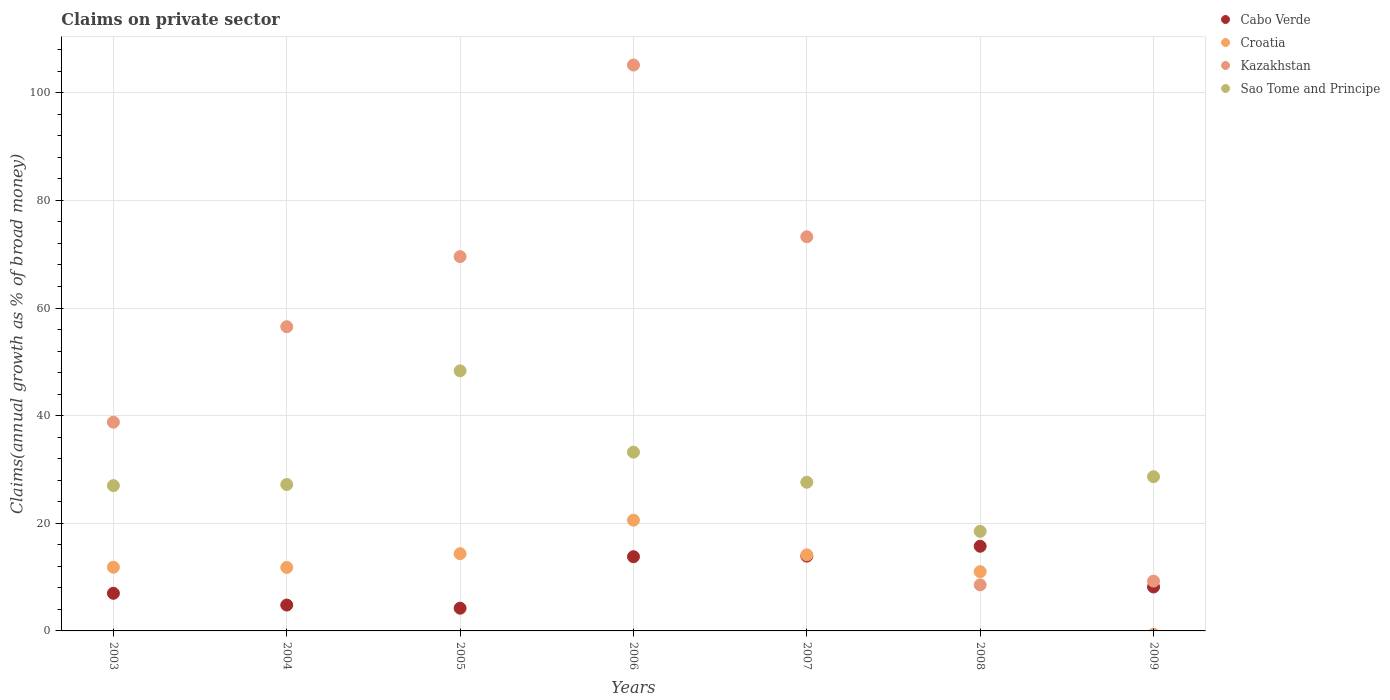How many different coloured dotlines are there?
Give a very brief answer. 4. What is the percentage of broad money claimed on private sector in Cabo Verde in 2009?
Your answer should be very brief. 8.17. Across all years, what is the maximum percentage of broad money claimed on private sector in Sao Tome and Principe?
Offer a very short reply. 48.33. Across all years, what is the minimum percentage of broad money claimed on private sector in Cabo Verde?
Your response must be concise. 4.22. In which year was the percentage of broad money claimed on private sector in Cabo Verde maximum?
Provide a short and direct response. 2008. What is the total percentage of broad money claimed on private sector in Croatia in the graph?
Your answer should be very brief. 83.72. What is the difference between the percentage of broad money claimed on private sector in Cabo Verde in 2006 and that in 2007?
Offer a very short reply. -0.11. What is the difference between the percentage of broad money claimed on private sector in Cabo Verde in 2006 and the percentage of broad money claimed on private sector in Croatia in 2005?
Provide a short and direct response. -0.56. What is the average percentage of broad money claimed on private sector in Cabo Verde per year?
Your answer should be compact. 9.66. In the year 2007, what is the difference between the percentage of broad money claimed on private sector in Croatia and percentage of broad money claimed on private sector in Cabo Verde?
Your answer should be compact. 0.24. In how many years, is the percentage of broad money claimed on private sector in Sao Tome and Principe greater than 52 %?
Keep it short and to the point. 0. What is the ratio of the percentage of broad money claimed on private sector in Kazakhstan in 2005 to that in 2008?
Give a very brief answer. 8.13. Is the percentage of broad money claimed on private sector in Kazakhstan in 2003 less than that in 2006?
Ensure brevity in your answer.  Yes. What is the difference between the highest and the second highest percentage of broad money claimed on private sector in Kazakhstan?
Your answer should be compact. 31.92. What is the difference between the highest and the lowest percentage of broad money claimed on private sector in Croatia?
Give a very brief answer. 20.58. In how many years, is the percentage of broad money claimed on private sector in Croatia greater than the average percentage of broad money claimed on private sector in Croatia taken over all years?
Offer a very short reply. 3. Is the sum of the percentage of broad money claimed on private sector in Kazakhstan in 2006 and 2008 greater than the maximum percentage of broad money claimed on private sector in Sao Tome and Principe across all years?
Give a very brief answer. Yes. Is it the case that in every year, the sum of the percentage of broad money claimed on private sector in Kazakhstan and percentage of broad money claimed on private sector in Sao Tome and Principe  is greater than the percentage of broad money claimed on private sector in Cabo Verde?
Give a very brief answer. Yes. Does the percentage of broad money claimed on private sector in Croatia monotonically increase over the years?
Your answer should be very brief. No. Is the percentage of broad money claimed on private sector in Kazakhstan strictly less than the percentage of broad money claimed on private sector in Sao Tome and Principe over the years?
Provide a succinct answer. No. How many dotlines are there?
Give a very brief answer. 4. What is the difference between two consecutive major ticks on the Y-axis?
Your answer should be compact. 20. Does the graph contain grids?
Keep it short and to the point. Yes. Where does the legend appear in the graph?
Offer a very short reply. Top right. How are the legend labels stacked?
Offer a terse response. Vertical. What is the title of the graph?
Your answer should be compact. Claims on private sector. Does "United States" appear as one of the legend labels in the graph?
Offer a terse response. No. What is the label or title of the X-axis?
Your answer should be compact. Years. What is the label or title of the Y-axis?
Ensure brevity in your answer.  Claims(annual growth as % of broad money). What is the Claims(annual growth as % of broad money) in Cabo Verde in 2003?
Your response must be concise. 6.99. What is the Claims(annual growth as % of broad money) in Croatia in 2003?
Offer a terse response. 11.84. What is the Claims(annual growth as % of broad money) in Kazakhstan in 2003?
Your answer should be very brief. 38.79. What is the Claims(annual growth as % of broad money) of Sao Tome and Principe in 2003?
Give a very brief answer. 27. What is the Claims(annual growth as % of broad money) of Cabo Verde in 2004?
Ensure brevity in your answer.  4.81. What is the Claims(annual growth as % of broad money) of Croatia in 2004?
Make the answer very short. 11.8. What is the Claims(annual growth as % of broad money) of Kazakhstan in 2004?
Offer a terse response. 56.53. What is the Claims(annual growth as % of broad money) of Sao Tome and Principe in 2004?
Your answer should be very brief. 27.21. What is the Claims(annual growth as % of broad money) in Cabo Verde in 2005?
Offer a terse response. 4.22. What is the Claims(annual growth as % of broad money) in Croatia in 2005?
Keep it short and to the point. 14.35. What is the Claims(annual growth as % of broad money) in Kazakhstan in 2005?
Give a very brief answer. 69.55. What is the Claims(annual growth as % of broad money) of Sao Tome and Principe in 2005?
Give a very brief answer. 48.33. What is the Claims(annual growth as % of broad money) in Cabo Verde in 2006?
Your answer should be compact. 13.79. What is the Claims(annual growth as % of broad money) of Croatia in 2006?
Provide a short and direct response. 20.58. What is the Claims(annual growth as % of broad money) in Kazakhstan in 2006?
Offer a terse response. 105.15. What is the Claims(annual growth as % of broad money) in Sao Tome and Principe in 2006?
Offer a terse response. 33.22. What is the Claims(annual growth as % of broad money) in Cabo Verde in 2007?
Provide a succinct answer. 13.9. What is the Claims(annual growth as % of broad money) in Croatia in 2007?
Provide a succinct answer. 14.14. What is the Claims(annual growth as % of broad money) in Kazakhstan in 2007?
Keep it short and to the point. 73.24. What is the Claims(annual growth as % of broad money) in Sao Tome and Principe in 2007?
Your response must be concise. 27.63. What is the Claims(annual growth as % of broad money) in Cabo Verde in 2008?
Make the answer very short. 15.73. What is the Claims(annual growth as % of broad money) in Croatia in 2008?
Your answer should be very brief. 11.01. What is the Claims(annual growth as % of broad money) of Kazakhstan in 2008?
Make the answer very short. 8.55. What is the Claims(annual growth as % of broad money) in Sao Tome and Principe in 2008?
Offer a very short reply. 18.51. What is the Claims(annual growth as % of broad money) of Cabo Verde in 2009?
Your answer should be compact. 8.17. What is the Claims(annual growth as % of broad money) in Croatia in 2009?
Offer a very short reply. 0. What is the Claims(annual growth as % of broad money) in Kazakhstan in 2009?
Your answer should be very brief. 9.25. What is the Claims(annual growth as % of broad money) of Sao Tome and Principe in 2009?
Your answer should be compact. 28.66. Across all years, what is the maximum Claims(annual growth as % of broad money) of Cabo Verde?
Your answer should be very brief. 15.73. Across all years, what is the maximum Claims(annual growth as % of broad money) of Croatia?
Offer a very short reply. 20.58. Across all years, what is the maximum Claims(annual growth as % of broad money) in Kazakhstan?
Provide a short and direct response. 105.15. Across all years, what is the maximum Claims(annual growth as % of broad money) of Sao Tome and Principe?
Offer a terse response. 48.33. Across all years, what is the minimum Claims(annual growth as % of broad money) in Cabo Verde?
Your answer should be very brief. 4.22. Across all years, what is the minimum Claims(annual growth as % of broad money) of Croatia?
Provide a succinct answer. 0. Across all years, what is the minimum Claims(annual growth as % of broad money) of Kazakhstan?
Give a very brief answer. 8.55. Across all years, what is the minimum Claims(annual growth as % of broad money) of Sao Tome and Principe?
Offer a terse response. 18.51. What is the total Claims(annual growth as % of broad money) in Cabo Verde in the graph?
Your answer should be very brief. 67.61. What is the total Claims(annual growth as % of broad money) in Croatia in the graph?
Provide a succinct answer. 83.72. What is the total Claims(annual growth as % of broad money) in Kazakhstan in the graph?
Your answer should be compact. 361.06. What is the total Claims(annual growth as % of broad money) of Sao Tome and Principe in the graph?
Your response must be concise. 210.55. What is the difference between the Claims(annual growth as % of broad money) of Cabo Verde in 2003 and that in 2004?
Keep it short and to the point. 2.19. What is the difference between the Claims(annual growth as % of broad money) of Croatia in 2003 and that in 2004?
Make the answer very short. 0.04. What is the difference between the Claims(annual growth as % of broad money) of Kazakhstan in 2003 and that in 2004?
Make the answer very short. -17.74. What is the difference between the Claims(annual growth as % of broad money) in Sao Tome and Principe in 2003 and that in 2004?
Give a very brief answer. -0.21. What is the difference between the Claims(annual growth as % of broad money) in Cabo Verde in 2003 and that in 2005?
Provide a short and direct response. 2.77. What is the difference between the Claims(annual growth as % of broad money) in Croatia in 2003 and that in 2005?
Ensure brevity in your answer.  -2.51. What is the difference between the Claims(annual growth as % of broad money) of Kazakhstan in 2003 and that in 2005?
Your answer should be compact. -30.76. What is the difference between the Claims(annual growth as % of broad money) of Sao Tome and Principe in 2003 and that in 2005?
Provide a short and direct response. -21.33. What is the difference between the Claims(annual growth as % of broad money) in Cabo Verde in 2003 and that in 2006?
Offer a terse response. -6.8. What is the difference between the Claims(annual growth as % of broad money) of Croatia in 2003 and that in 2006?
Keep it short and to the point. -8.74. What is the difference between the Claims(annual growth as % of broad money) of Kazakhstan in 2003 and that in 2006?
Give a very brief answer. -66.36. What is the difference between the Claims(annual growth as % of broad money) in Sao Tome and Principe in 2003 and that in 2006?
Make the answer very short. -6.22. What is the difference between the Claims(annual growth as % of broad money) of Cabo Verde in 2003 and that in 2007?
Provide a short and direct response. -6.91. What is the difference between the Claims(annual growth as % of broad money) in Croatia in 2003 and that in 2007?
Your response must be concise. -2.31. What is the difference between the Claims(annual growth as % of broad money) of Kazakhstan in 2003 and that in 2007?
Your answer should be very brief. -34.45. What is the difference between the Claims(annual growth as % of broad money) in Sao Tome and Principe in 2003 and that in 2007?
Provide a succinct answer. -0.63. What is the difference between the Claims(annual growth as % of broad money) in Cabo Verde in 2003 and that in 2008?
Keep it short and to the point. -8.74. What is the difference between the Claims(annual growth as % of broad money) of Croatia in 2003 and that in 2008?
Ensure brevity in your answer.  0.83. What is the difference between the Claims(annual growth as % of broad money) in Kazakhstan in 2003 and that in 2008?
Your response must be concise. 30.24. What is the difference between the Claims(annual growth as % of broad money) in Sao Tome and Principe in 2003 and that in 2008?
Make the answer very short. 8.49. What is the difference between the Claims(annual growth as % of broad money) of Cabo Verde in 2003 and that in 2009?
Give a very brief answer. -1.18. What is the difference between the Claims(annual growth as % of broad money) in Kazakhstan in 2003 and that in 2009?
Give a very brief answer. 29.54. What is the difference between the Claims(annual growth as % of broad money) in Sao Tome and Principe in 2003 and that in 2009?
Keep it short and to the point. -1.66. What is the difference between the Claims(annual growth as % of broad money) of Cabo Verde in 2004 and that in 2005?
Your response must be concise. 0.59. What is the difference between the Claims(annual growth as % of broad money) in Croatia in 2004 and that in 2005?
Give a very brief answer. -2.56. What is the difference between the Claims(annual growth as % of broad money) in Kazakhstan in 2004 and that in 2005?
Ensure brevity in your answer.  -13.02. What is the difference between the Claims(annual growth as % of broad money) in Sao Tome and Principe in 2004 and that in 2005?
Ensure brevity in your answer.  -21.12. What is the difference between the Claims(annual growth as % of broad money) of Cabo Verde in 2004 and that in 2006?
Give a very brief answer. -8.98. What is the difference between the Claims(annual growth as % of broad money) in Croatia in 2004 and that in 2006?
Your response must be concise. -8.78. What is the difference between the Claims(annual growth as % of broad money) in Kazakhstan in 2004 and that in 2006?
Give a very brief answer. -48.63. What is the difference between the Claims(annual growth as % of broad money) in Sao Tome and Principe in 2004 and that in 2006?
Offer a terse response. -6.01. What is the difference between the Claims(annual growth as % of broad money) in Cabo Verde in 2004 and that in 2007?
Your response must be concise. -9.09. What is the difference between the Claims(annual growth as % of broad money) of Croatia in 2004 and that in 2007?
Your answer should be very brief. -2.35. What is the difference between the Claims(annual growth as % of broad money) of Kazakhstan in 2004 and that in 2007?
Your response must be concise. -16.71. What is the difference between the Claims(annual growth as % of broad money) in Sao Tome and Principe in 2004 and that in 2007?
Give a very brief answer. -0.42. What is the difference between the Claims(annual growth as % of broad money) of Cabo Verde in 2004 and that in 2008?
Provide a short and direct response. -10.92. What is the difference between the Claims(annual growth as % of broad money) in Croatia in 2004 and that in 2008?
Offer a very short reply. 0.79. What is the difference between the Claims(annual growth as % of broad money) in Kazakhstan in 2004 and that in 2008?
Offer a terse response. 47.97. What is the difference between the Claims(annual growth as % of broad money) of Sao Tome and Principe in 2004 and that in 2008?
Your response must be concise. 8.7. What is the difference between the Claims(annual growth as % of broad money) in Cabo Verde in 2004 and that in 2009?
Your answer should be compact. -3.37. What is the difference between the Claims(annual growth as % of broad money) of Kazakhstan in 2004 and that in 2009?
Provide a short and direct response. 47.28. What is the difference between the Claims(annual growth as % of broad money) in Sao Tome and Principe in 2004 and that in 2009?
Provide a short and direct response. -1.45. What is the difference between the Claims(annual growth as % of broad money) of Cabo Verde in 2005 and that in 2006?
Your answer should be compact. -9.57. What is the difference between the Claims(annual growth as % of broad money) of Croatia in 2005 and that in 2006?
Offer a terse response. -6.23. What is the difference between the Claims(annual growth as % of broad money) of Kazakhstan in 2005 and that in 2006?
Ensure brevity in your answer.  -35.6. What is the difference between the Claims(annual growth as % of broad money) of Sao Tome and Principe in 2005 and that in 2006?
Offer a very short reply. 15.12. What is the difference between the Claims(annual growth as % of broad money) of Cabo Verde in 2005 and that in 2007?
Ensure brevity in your answer.  -9.68. What is the difference between the Claims(annual growth as % of broad money) in Croatia in 2005 and that in 2007?
Give a very brief answer. 0.21. What is the difference between the Claims(annual growth as % of broad money) of Kazakhstan in 2005 and that in 2007?
Offer a very short reply. -3.69. What is the difference between the Claims(annual growth as % of broad money) in Sao Tome and Principe in 2005 and that in 2007?
Offer a very short reply. 20.7. What is the difference between the Claims(annual growth as % of broad money) in Cabo Verde in 2005 and that in 2008?
Provide a succinct answer. -11.51. What is the difference between the Claims(annual growth as % of broad money) of Croatia in 2005 and that in 2008?
Provide a succinct answer. 3.34. What is the difference between the Claims(annual growth as % of broad money) in Kazakhstan in 2005 and that in 2008?
Make the answer very short. 61. What is the difference between the Claims(annual growth as % of broad money) in Sao Tome and Principe in 2005 and that in 2008?
Give a very brief answer. 29.83. What is the difference between the Claims(annual growth as % of broad money) in Cabo Verde in 2005 and that in 2009?
Ensure brevity in your answer.  -3.95. What is the difference between the Claims(annual growth as % of broad money) of Kazakhstan in 2005 and that in 2009?
Ensure brevity in your answer.  60.3. What is the difference between the Claims(annual growth as % of broad money) in Sao Tome and Principe in 2005 and that in 2009?
Your response must be concise. 19.67. What is the difference between the Claims(annual growth as % of broad money) of Cabo Verde in 2006 and that in 2007?
Offer a terse response. -0.11. What is the difference between the Claims(annual growth as % of broad money) of Croatia in 2006 and that in 2007?
Your answer should be very brief. 6.44. What is the difference between the Claims(annual growth as % of broad money) in Kazakhstan in 2006 and that in 2007?
Offer a very short reply. 31.92. What is the difference between the Claims(annual growth as % of broad money) of Sao Tome and Principe in 2006 and that in 2007?
Provide a succinct answer. 5.59. What is the difference between the Claims(annual growth as % of broad money) of Cabo Verde in 2006 and that in 2008?
Your answer should be very brief. -1.94. What is the difference between the Claims(annual growth as % of broad money) of Croatia in 2006 and that in 2008?
Make the answer very short. 9.57. What is the difference between the Claims(annual growth as % of broad money) in Kazakhstan in 2006 and that in 2008?
Provide a succinct answer. 96.6. What is the difference between the Claims(annual growth as % of broad money) of Sao Tome and Principe in 2006 and that in 2008?
Keep it short and to the point. 14.71. What is the difference between the Claims(annual growth as % of broad money) of Cabo Verde in 2006 and that in 2009?
Provide a succinct answer. 5.62. What is the difference between the Claims(annual growth as % of broad money) in Kazakhstan in 2006 and that in 2009?
Give a very brief answer. 95.9. What is the difference between the Claims(annual growth as % of broad money) in Sao Tome and Principe in 2006 and that in 2009?
Offer a very short reply. 4.56. What is the difference between the Claims(annual growth as % of broad money) in Cabo Verde in 2007 and that in 2008?
Make the answer very short. -1.83. What is the difference between the Claims(annual growth as % of broad money) in Croatia in 2007 and that in 2008?
Your answer should be compact. 3.14. What is the difference between the Claims(annual growth as % of broad money) of Kazakhstan in 2007 and that in 2008?
Your answer should be very brief. 64.68. What is the difference between the Claims(annual growth as % of broad money) of Sao Tome and Principe in 2007 and that in 2008?
Your answer should be compact. 9.12. What is the difference between the Claims(annual growth as % of broad money) of Cabo Verde in 2007 and that in 2009?
Your response must be concise. 5.73. What is the difference between the Claims(annual growth as % of broad money) of Kazakhstan in 2007 and that in 2009?
Ensure brevity in your answer.  63.98. What is the difference between the Claims(annual growth as % of broad money) of Sao Tome and Principe in 2007 and that in 2009?
Provide a succinct answer. -1.03. What is the difference between the Claims(annual growth as % of broad money) of Cabo Verde in 2008 and that in 2009?
Give a very brief answer. 7.56. What is the difference between the Claims(annual growth as % of broad money) of Kazakhstan in 2008 and that in 2009?
Ensure brevity in your answer.  -0.7. What is the difference between the Claims(annual growth as % of broad money) in Sao Tome and Principe in 2008 and that in 2009?
Your response must be concise. -10.15. What is the difference between the Claims(annual growth as % of broad money) of Cabo Verde in 2003 and the Claims(annual growth as % of broad money) of Croatia in 2004?
Keep it short and to the point. -4.8. What is the difference between the Claims(annual growth as % of broad money) in Cabo Verde in 2003 and the Claims(annual growth as % of broad money) in Kazakhstan in 2004?
Your answer should be very brief. -49.54. What is the difference between the Claims(annual growth as % of broad money) in Cabo Verde in 2003 and the Claims(annual growth as % of broad money) in Sao Tome and Principe in 2004?
Your answer should be very brief. -20.22. What is the difference between the Claims(annual growth as % of broad money) in Croatia in 2003 and the Claims(annual growth as % of broad money) in Kazakhstan in 2004?
Keep it short and to the point. -44.69. What is the difference between the Claims(annual growth as % of broad money) of Croatia in 2003 and the Claims(annual growth as % of broad money) of Sao Tome and Principe in 2004?
Your response must be concise. -15.37. What is the difference between the Claims(annual growth as % of broad money) of Kazakhstan in 2003 and the Claims(annual growth as % of broad money) of Sao Tome and Principe in 2004?
Make the answer very short. 11.58. What is the difference between the Claims(annual growth as % of broad money) of Cabo Verde in 2003 and the Claims(annual growth as % of broad money) of Croatia in 2005?
Keep it short and to the point. -7.36. What is the difference between the Claims(annual growth as % of broad money) in Cabo Verde in 2003 and the Claims(annual growth as % of broad money) in Kazakhstan in 2005?
Give a very brief answer. -62.56. What is the difference between the Claims(annual growth as % of broad money) of Cabo Verde in 2003 and the Claims(annual growth as % of broad money) of Sao Tome and Principe in 2005?
Your answer should be compact. -41.34. What is the difference between the Claims(annual growth as % of broad money) in Croatia in 2003 and the Claims(annual growth as % of broad money) in Kazakhstan in 2005?
Keep it short and to the point. -57.71. What is the difference between the Claims(annual growth as % of broad money) of Croatia in 2003 and the Claims(annual growth as % of broad money) of Sao Tome and Principe in 2005?
Ensure brevity in your answer.  -36.5. What is the difference between the Claims(annual growth as % of broad money) of Kazakhstan in 2003 and the Claims(annual growth as % of broad money) of Sao Tome and Principe in 2005?
Offer a very short reply. -9.54. What is the difference between the Claims(annual growth as % of broad money) of Cabo Verde in 2003 and the Claims(annual growth as % of broad money) of Croatia in 2006?
Provide a succinct answer. -13.59. What is the difference between the Claims(annual growth as % of broad money) of Cabo Verde in 2003 and the Claims(annual growth as % of broad money) of Kazakhstan in 2006?
Make the answer very short. -98.16. What is the difference between the Claims(annual growth as % of broad money) in Cabo Verde in 2003 and the Claims(annual growth as % of broad money) in Sao Tome and Principe in 2006?
Your answer should be very brief. -26.22. What is the difference between the Claims(annual growth as % of broad money) in Croatia in 2003 and the Claims(annual growth as % of broad money) in Kazakhstan in 2006?
Provide a succinct answer. -93.32. What is the difference between the Claims(annual growth as % of broad money) in Croatia in 2003 and the Claims(annual growth as % of broad money) in Sao Tome and Principe in 2006?
Ensure brevity in your answer.  -21.38. What is the difference between the Claims(annual growth as % of broad money) of Kazakhstan in 2003 and the Claims(annual growth as % of broad money) of Sao Tome and Principe in 2006?
Your answer should be compact. 5.57. What is the difference between the Claims(annual growth as % of broad money) in Cabo Verde in 2003 and the Claims(annual growth as % of broad money) in Croatia in 2007?
Provide a succinct answer. -7.15. What is the difference between the Claims(annual growth as % of broad money) in Cabo Verde in 2003 and the Claims(annual growth as % of broad money) in Kazakhstan in 2007?
Give a very brief answer. -66.24. What is the difference between the Claims(annual growth as % of broad money) in Cabo Verde in 2003 and the Claims(annual growth as % of broad money) in Sao Tome and Principe in 2007?
Keep it short and to the point. -20.64. What is the difference between the Claims(annual growth as % of broad money) of Croatia in 2003 and the Claims(annual growth as % of broad money) of Kazakhstan in 2007?
Give a very brief answer. -61.4. What is the difference between the Claims(annual growth as % of broad money) of Croatia in 2003 and the Claims(annual growth as % of broad money) of Sao Tome and Principe in 2007?
Your response must be concise. -15.79. What is the difference between the Claims(annual growth as % of broad money) of Kazakhstan in 2003 and the Claims(annual growth as % of broad money) of Sao Tome and Principe in 2007?
Your answer should be compact. 11.16. What is the difference between the Claims(annual growth as % of broad money) in Cabo Verde in 2003 and the Claims(annual growth as % of broad money) in Croatia in 2008?
Keep it short and to the point. -4.02. What is the difference between the Claims(annual growth as % of broad money) in Cabo Verde in 2003 and the Claims(annual growth as % of broad money) in Kazakhstan in 2008?
Make the answer very short. -1.56. What is the difference between the Claims(annual growth as % of broad money) of Cabo Verde in 2003 and the Claims(annual growth as % of broad money) of Sao Tome and Principe in 2008?
Provide a short and direct response. -11.51. What is the difference between the Claims(annual growth as % of broad money) in Croatia in 2003 and the Claims(annual growth as % of broad money) in Kazakhstan in 2008?
Offer a very short reply. 3.28. What is the difference between the Claims(annual growth as % of broad money) in Croatia in 2003 and the Claims(annual growth as % of broad money) in Sao Tome and Principe in 2008?
Your answer should be compact. -6.67. What is the difference between the Claims(annual growth as % of broad money) in Kazakhstan in 2003 and the Claims(annual growth as % of broad money) in Sao Tome and Principe in 2008?
Offer a very short reply. 20.28. What is the difference between the Claims(annual growth as % of broad money) in Cabo Verde in 2003 and the Claims(annual growth as % of broad money) in Kazakhstan in 2009?
Your answer should be very brief. -2.26. What is the difference between the Claims(annual growth as % of broad money) of Cabo Verde in 2003 and the Claims(annual growth as % of broad money) of Sao Tome and Principe in 2009?
Offer a terse response. -21.67. What is the difference between the Claims(annual growth as % of broad money) in Croatia in 2003 and the Claims(annual growth as % of broad money) in Kazakhstan in 2009?
Ensure brevity in your answer.  2.59. What is the difference between the Claims(annual growth as % of broad money) in Croatia in 2003 and the Claims(annual growth as % of broad money) in Sao Tome and Principe in 2009?
Keep it short and to the point. -16.82. What is the difference between the Claims(annual growth as % of broad money) in Kazakhstan in 2003 and the Claims(annual growth as % of broad money) in Sao Tome and Principe in 2009?
Your response must be concise. 10.13. What is the difference between the Claims(annual growth as % of broad money) in Cabo Verde in 2004 and the Claims(annual growth as % of broad money) in Croatia in 2005?
Your answer should be very brief. -9.54. What is the difference between the Claims(annual growth as % of broad money) of Cabo Verde in 2004 and the Claims(annual growth as % of broad money) of Kazakhstan in 2005?
Offer a very short reply. -64.75. What is the difference between the Claims(annual growth as % of broad money) in Cabo Verde in 2004 and the Claims(annual growth as % of broad money) in Sao Tome and Principe in 2005?
Offer a terse response. -43.53. What is the difference between the Claims(annual growth as % of broad money) in Croatia in 2004 and the Claims(annual growth as % of broad money) in Kazakhstan in 2005?
Provide a succinct answer. -57.76. What is the difference between the Claims(annual growth as % of broad money) of Croatia in 2004 and the Claims(annual growth as % of broad money) of Sao Tome and Principe in 2005?
Provide a short and direct response. -36.54. What is the difference between the Claims(annual growth as % of broad money) of Kazakhstan in 2004 and the Claims(annual growth as % of broad money) of Sao Tome and Principe in 2005?
Offer a terse response. 8.19. What is the difference between the Claims(annual growth as % of broad money) in Cabo Verde in 2004 and the Claims(annual growth as % of broad money) in Croatia in 2006?
Ensure brevity in your answer.  -15.77. What is the difference between the Claims(annual growth as % of broad money) of Cabo Verde in 2004 and the Claims(annual growth as % of broad money) of Kazakhstan in 2006?
Your answer should be very brief. -100.35. What is the difference between the Claims(annual growth as % of broad money) in Cabo Verde in 2004 and the Claims(annual growth as % of broad money) in Sao Tome and Principe in 2006?
Provide a succinct answer. -28.41. What is the difference between the Claims(annual growth as % of broad money) of Croatia in 2004 and the Claims(annual growth as % of broad money) of Kazakhstan in 2006?
Ensure brevity in your answer.  -93.36. What is the difference between the Claims(annual growth as % of broad money) of Croatia in 2004 and the Claims(annual growth as % of broad money) of Sao Tome and Principe in 2006?
Offer a very short reply. -21.42. What is the difference between the Claims(annual growth as % of broad money) of Kazakhstan in 2004 and the Claims(annual growth as % of broad money) of Sao Tome and Principe in 2006?
Provide a succinct answer. 23.31. What is the difference between the Claims(annual growth as % of broad money) of Cabo Verde in 2004 and the Claims(annual growth as % of broad money) of Croatia in 2007?
Ensure brevity in your answer.  -9.34. What is the difference between the Claims(annual growth as % of broad money) in Cabo Verde in 2004 and the Claims(annual growth as % of broad money) in Kazakhstan in 2007?
Ensure brevity in your answer.  -68.43. What is the difference between the Claims(annual growth as % of broad money) of Cabo Verde in 2004 and the Claims(annual growth as % of broad money) of Sao Tome and Principe in 2007?
Give a very brief answer. -22.82. What is the difference between the Claims(annual growth as % of broad money) of Croatia in 2004 and the Claims(annual growth as % of broad money) of Kazakhstan in 2007?
Your answer should be very brief. -61.44. What is the difference between the Claims(annual growth as % of broad money) in Croatia in 2004 and the Claims(annual growth as % of broad money) in Sao Tome and Principe in 2007?
Make the answer very short. -15.84. What is the difference between the Claims(annual growth as % of broad money) of Kazakhstan in 2004 and the Claims(annual growth as % of broad money) of Sao Tome and Principe in 2007?
Ensure brevity in your answer.  28.9. What is the difference between the Claims(annual growth as % of broad money) of Cabo Verde in 2004 and the Claims(annual growth as % of broad money) of Croatia in 2008?
Your response must be concise. -6.2. What is the difference between the Claims(annual growth as % of broad money) in Cabo Verde in 2004 and the Claims(annual growth as % of broad money) in Kazakhstan in 2008?
Your response must be concise. -3.75. What is the difference between the Claims(annual growth as % of broad money) in Cabo Verde in 2004 and the Claims(annual growth as % of broad money) in Sao Tome and Principe in 2008?
Give a very brief answer. -13.7. What is the difference between the Claims(annual growth as % of broad money) in Croatia in 2004 and the Claims(annual growth as % of broad money) in Kazakhstan in 2008?
Provide a short and direct response. 3.24. What is the difference between the Claims(annual growth as % of broad money) in Croatia in 2004 and the Claims(annual growth as % of broad money) in Sao Tome and Principe in 2008?
Keep it short and to the point. -6.71. What is the difference between the Claims(annual growth as % of broad money) of Kazakhstan in 2004 and the Claims(annual growth as % of broad money) of Sao Tome and Principe in 2008?
Provide a short and direct response. 38.02. What is the difference between the Claims(annual growth as % of broad money) in Cabo Verde in 2004 and the Claims(annual growth as % of broad money) in Kazakhstan in 2009?
Keep it short and to the point. -4.45. What is the difference between the Claims(annual growth as % of broad money) of Cabo Verde in 2004 and the Claims(annual growth as % of broad money) of Sao Tome and Principe in 2009?
Your response must be concise. -23.85. What is the difference between the Claims(annual growth as % of broad money) of Croatia in 2004 and the Claims(annual growth as % of broad money) of Kazakhstan in 2009?
Offer a very short reply. 2.54. What is the difference between the Claims(annual growth as % of broad money) of Croatia in 2004 and the Claims(annual growth as % of broad money) of Sao Tome and Principe in 2009?
Your response must be concise. -16.86. What is the difference between the Claims(annual growth as % of broad money) in Kazakhstan in 2004 and the Claims(annual growth as % of broad money) in Sao Tome and Principe in 2009?
Offer a very short reply. 27.87. What is the difference between the Claims(annual growth as % of broad money) of Cabo Verde in 2005 and the Claims(annual growth as % of broad money) of Croatia in 2006?
Your response must be concise. -16.36. What is the difference between the Claims(annual growth as % of broad money) in Cabo Verde in 2005 and the Claims(annual growth as % of broad money) in Kazakhstan in 2006?
Ensure brevity in your answer.  -100.93. What is the difference between the Claims(annual growth as % of broad money) of Cabo Verde in 2005 and the Claims(annual growth as % of broad money) of Sao Tome and Principe in 2006?
Offer a very short reply. -29. What is the difference between the Claims(annual growth as % of broad money) in Croatia in 2005 and the Claims(annual growth as % of broad money) in Kazakhstan in 2006?
Your answer should be compact. -90.8. What is the difference between the Claims(annual growth as % of broad money) of Croatia in 2005 and the Claims(annual growth as % of broad money) of Sao Tome and Principe in 2006?
Offer a very short reply. -18.87. What is the difference between the Claims(annual growth as % of broad money) in Kazakhstan in 2005 and the Claims(annual growth as % of broad money) in Sao Tome and Principe in 2006?
Offer a terse response. 36.34. What is the difference between the Claims(annual growth as % of broad money) in Cabo Verde in 2005 and the Claims(annual growth as % of broad money) in Croatia in 2007?
Your answer should be very brief. -9.92. What is the difference between the Claims(annual growth as % of broad money) of Cabo Verde in 2005 and the Claims(annual growth as % of broad money) of Kazakhstan in 2007?
Make the answer very short. -69.02. What is the difference between the Claims(annual growth as % of broad money) of Cabo Verde in 2005 and the Claims(annual growth as % of broad money) of Sao Tome and Principe in 2007?
Your answer should be compact. -23.41. What is the difference between the Claims(annual growth as % of broad money) of Croatia in 2005 and the Claims(annual growth as % of broad money) of Kazakhstan in 2007?
Provide a succinct answer. -58.89. What is the difference between the Claims(annual growth as % of broad money) of Croatia in 2005 and the Claims(annual growth as % of broad money) of Sao Tome and Principe in 2007?
Your answer should be very brief. -13.28. What is the difference between the Claims(annual growth as % of broad money) of Kazakhstan in 2005 and the Claims(annual growth as % of broad money) of Sao Tome and Principe in 2007?
Your response must be concise. 41.92. What is the difference between the Claims(annual growth as % of broad money) in Cabo Verde in 2005 and the Claims(annual growth as % of broad money) in Croatia in 2008?
Ensure brevity in your answer.  -6.79. What is the difference between the Claims(annual growth as % of broad money) of Cabo Verde in 2005 and the Claims(annual growth as % of broad money) of Kazakhstan in 2008?
Offer a terse response. -4.33. What is the difference between the Claims(annual growth as % of broad money) of Cabo Verde in 2005 and the Claims(annual growth as % of broad money) of Sao Tome and Principe in 2008?
Offer a terse response. -14.29. What is the difference between the Claims(annual growth as % of broad money) in Croatia in 2005 and the Claims(annual growth as % of broad money) in Kazakhstan in 2008?
Provide a succinct answer. 5.8. What is the difference between the Claims(annual growth as % of broad money) in Croatia in 2005 and the Claims(annual growth as % of broad money) in Sao Tome and Principe in 2008?
Offer a terse response. -4.15. What is the difference between the Claims(annual growth as % of broad money) of Kazakhstan in 2005 and the Claims(annual growth as % of broad money) of Sao Tome and Principe in 2008?
Make the answer very short. 51.05. What is the difference between the Claims(annual growth as % of broad money) of Cabo Verde in 2005 and the Claims(annual growth as % of broad money) of Kazakhstan in 2009?
Your answer should be very brief. -5.03. What is the difference between the Claims(annual growth as % of broad money) in Cabo Verde in 2005 and the Claims(annual growth as % of broad money) in Sao Tome and Principe in 2009?
Provide a short and direct response. -24.44. What is the difference between the Claims(annual growth as % of broad money) in Croatia in 2005 and the Claims(annual growth as % of broad money) in Kazakhstan in 2009?
Offer a very short reply. 5.1. What is the difference between the Claims(annual growth as % of broad money) of Croatia in 2005 and the Claims(annual growth as % of broad money) of Sao Tome and Principe in 2009?
Offer a very short reply. -14.31. What is the difference between the Claims(annual growth as % of broad money) in Kazakhstan in 2005 and the Claims(annual growth as % of broad money) in Sao Tome and Principe in 2009?
Provide a short and direct response. 40.89. What is the difference between the Claims(annual growth as % of broad money) in Cabo Verde in 2006 and the Claims(annual growth as % of broad money) in Croatia in 2007?
Offer a very short reply. -0.35. What is the difference between the Claims(annual growth as % of broad money) in Cabo Verde in 2006 and the Claims(annual growth as % of broad money) in Kazakhstan in 2007?
Your answer should be compact. -59.45. What is the difference between the Claims(annual growth as % of broad money) of Cabo Verde in 2006 and the Claims(annual growth as % of broad money) of Sao Tome and Principe in 2007?
Give a very brief answer. -13.84. What is the difference between the Claims(annual growth as % of broad money) of Croatia in 2006 and the Claims(annual growth as % of broad money) of Kazakhstan in 2007?
Provide a short and direct response. -52.66. What is the difference between the Claims(annual growth as % of broad money) of Croatia in 2006 and the Claims(annual growth as % of broad money) of Sao Tome and Principe in 2007?
Give a very brief answer. -7.05. What is the difference between the Claims(annual growth as % of broad money) of Kazakhstan in 2006 and the Claims(annual growth as % of broad money) of Sao Tome and Principe in 2007?
Provide a succinct answer. 77.52. What is the difference between the Claims(annual growth as % of broad money) of Cabo Verde in 2006 and the Claims(annual growth as % of broad money) of Croatia in 2008?
Offer a terse response. 2.78. What is the difference between the Claims(annual growth as % of broad money) of Cabo Verde in 2006 and the Claims(annual growth as % of broad money) of Kazakhstan in 2008?
Keep it short and to the point. 5.24. What is the difference between the Claims(annual growth as % of broad money) in Cabo Verde in 2006 and the Claims(annual growth as % of broad money) in Sao Tome and Principe in 2008?
Make the answer very short. -4.71. What is the difference between the Claims(annual growth as % of broad money) of Croatia in 2006 and the Claims(annual growth as % of broad money) of Kazakhstan in 2008?
Provide a short and direct response. 12.03. What is the difference between the Claims(annual growth as % of broad money) in Croatia in 2006 and the Claims(annual growth as % of broad money) in Sao Tome and Principe in 2008?
Offer a terse response. 2.07. What is the difference between the Claims(annual growth as % of broad money) in Kazakhstan in 2006 and the Claims(annual growth as % of broad money) in Sao Tome and Principe in 2008?
Give a very brief answer. 86.65. What is the difference between the Claims(annual growth as % of broad money) of Cabo Verde in 2006 and the Claims(annual growth as % of broad money) of Kazakhstan in 2009?
Your answer should be compact. 4.54. What is the difference between the Claims(annual growth as % of broad money) of Cabo Verde in 2006 and the Claims(annual growth as % of broad money) of Sao Tome and Principe in 2009?
Your answer should be very brief. -14.87. What is the difference between the Claims(annual growth as % of broad money) in Croatia in 2006 and the Claims(annual growth as % of broad money) in Kazakhstan in 2009?
Ensure brevity in your answer.  11.33. What is the difference between the Claims(annual growth as % of broad money) in Croatia in 2006 and the Claims(annual growth as % of broad money) in Sao Tome and Principe in 2009?
Your answer should be very brief. -8.08. What is the difference between the Claims(annual growth as % of broad money) in Kazakhstan in 2006 and the Claims(annual growth as % of broad money) in Sao Tome and Principe in 2009?
Your answer should be very brief. 76.49. What is the difference between the Claims(annual growth as % of broad money) in Cabo Verde in 2007 and the Claims(annual growth as % of broad money) in Croatia in 2008?
Offer a terse response. 2.89. What is the difference between the Claims(annual growth as % of broad money) in Cabo Verde in 2007 and the Claims(annual growth as % of broad money) in Kazakhstan in 2008?
Your answer should be compact. 5.35. What is the difference between the Claims(annual growth as % of broad money) in Cabo Verde in 2007 and the Claims(annual growth as % of broad money) in Sao Tome and Principe in 2008?
Offer a terse response. -4.61. What is the difference between the Claims(annual growth as % of broad money) of Croatia in 2007 and the Claims(annual growth as % of broad money) of Kazakhstan in 2008?
Provide a short and direct response. 5.59. What is the difference between the Claims(annual growth as % of broad money) in Croatia in 2007 and the Claims(annual growth as % of broad money) in Sao Tome and Principe in 2008?
Keep it short and to the point. -4.36. What is the difference between the Claims(annual growth as % of broad money) of Kazakhstan in 2007 and the Claims(annual growth as % of broad money) of Sao Tome and Principe in 2008?
Your answer should be compact. 54.73. What is the difference between the Claims(annual growth as % of broad money) of Cabo Verde in 2007 and the Claims(annual growth as % of broad money) of Kazakhstan in 2009?
Offer a very short reply. 4.65. What is the difference between the Claims(annual growth as % of broad money) of Cabo Verde in 2007 and the Claims(annual growth as % of broad money) of Sao Tome and Principe in 2009?
Provide a succinct answer. -14.76. What is the difference between the Claims(annual growth as % of broad money) of Croatia in 2007 and the Claims(annual growth as % of broad money) of Kazakhstan in 2009?
Offer a terse response. 4.89. What is the difference between the Claims(annual growth as % of broad money) of Croatia in 2007 and the Claims(annual growth as % of broad money) of Sao Tome and Principe in 2009?
Your answer should be compact. -14.52. What is the difference between the Claims(annual growth as % of broad money) in Kazakhstan in 2007 and the Claims(annual growth as % of broad money) in Sao Tome and Principe in 2009?
Provide a succinct answer. 44.58. What is the difference between the Claims(annual growth as % of broad money) of Cabo Verde in 2008 and the Claims(annual growth as % of broad money) of Kazakhstan in 2009?
Give a very brief answer. 6.48. What is the difference between the Claims(annual growth as % of broad money) in Cabo Verde in 2008 and the Claims(annual growth as % of broad money) in Sao Tome and Principe in 2009?
Your response must be concise. -12.93. What is the difference between the Claims(annual growth as % of broad money) of Croatia in 2008 and the Claims(annual growth as % of broad money) of Kazakhstan in 2009?
Ensure brevity in your answer.  1.76. What is the difference between the Claims(annual growth as % of broad money) of Croatia in 2008 and the Claims(annual growth as % of broad money) of Sao Tome and Principe in 2009?
Give a very brief answer. -17.65. What is the difference between the Claims(annual growth as % of broad money) of Kazakhstan in 2008 and the Claims(annual growth as % of broad money) of Sao Tome and Principe in 2009?
Offer a very short reply. -20.11. What is the average Claims(annual growth as % of broad money) in Cabo Verde per year?
Your answer should be compact. 9.66. What is the average Claims(annual growth as % of broad money) in Croatia per year?
Ensure brevity in your answer.  11.96. What is the average Claims(annual growth as % of broad money) in Kazakhstan per year?
Your answer should be compact. 51.58. What is the average Claims(annual growth as % of broad money) of Sao Tome and Principe per year?
Offer a terse response. 30.08. In the year 2003, what is the difference between the Claims(annual growth as % of broad money) of Cabo Verde and Claims(annual growth as % of broad money) of Croatia?
Provide a succinct answer. -4.84. In the year 2003, what is the difference between the Claims(annual growth as % of broad money) of Cabo Verde and Claims(annual growth as % of broad money) of Kazakhstan?
Provide a short and direct response. -31.8. In the year 2003, what is the difference between the Claims(annual growth as % of broad money) of Cabo Verde and Claims(annual growth as % of broad money) of Sao Tome and Principe?
Your response must be concise. -20.01. In the year 2003, what is the difference between the Claims(annual growth as % of broad money) of Croatia and Claims(annual growth as % of broad money) of Kazakhstan?
Offer a terse response. -26.95. In the year 2003, what is the difference between the Claims(annual growth as % of broad money) of Croatia and Claims(annual growth as % of broad money) of Sao Tome and Principe?
Offer a very short reply. -15.16. In the year 2003, what is the difference between the Claims(annual growth as % of broad money) of Kazakhstan and Claims(annual growth as % of broad money) of Sao Tome and Principe?
Your response must be concise. 11.79. In the year 2004, what is the difference between the Claims(annual growth as % of broad money) in Cabo Verde and Claims(annual growth as % of broad money) in Croatia?
Offer a terse response. -6.99. In the year 2004, what is the difference between the Claims(annual growth as % of broad money) in Cabo Verde and Claims(annual growth as % of broad money) in Kazakhstan?
Provide a short and direct response. -51.72. In the year 2004, what is the difference between the Claims(annual growth as % of broad money) of Cabo Verde and Claims(annual growth as % of broad money) of Sao Tome and Principe?
Keep it short and to the point. -22.4. In the year 2004, what is the difference between the Claims(annual growth as % of broad money) of Croatia and Claims(annual growth as % of broad money) of Kazakhstan?
Your answer should be very brief. -44.73. In the year 2004, what is the difference between the Claims(annual growth as % of broad money) of Croatia and Claims(annual growth as % of broad money) of Sao Tome and Principe?
Provide a short and direct response. -15.41. In the year 2004, what is the difference between the Claims(annual growth as % of broad money) in Kazakhstan and Claims(annual growth as % of broad money) in Sao Tome and Principe?
Your answer should be compact. 29.32. In the year 2005, what is the difference between the Claims(annual growth as % of broad money) of Cabo Verde and Claims(annual growth as % of broad money) of Croatia?
Provide a succinct answer. -10.13. In the year 2005, what is the difference between the Claims(annual growth as % of broad money) in Cabo Verde and Claims(annual growth as % of broad money) in Kazakhstan?
Your response must be concise. -65.33. In the year 2005, what is the difference between the Claims(annual growth as % of broad money) of Cabo Verde and Claims(annual growth as % of broad money) of Sao Tome and Principe?
Keep it short and to the point. -44.11. In the year 2005, what is the difference between the Claims(annual growth as % of broad money) of Croatia and Claims(annual growth as % of broad money) of Kazakhstan?
Offer a very short reply. -55.2. In the year 2005, what is the difference between the Claims(annual growth as % of broad money) of Croatia and Claims(annual growth as % of broad money) of Sao Tome and Principe?
Make the answer very short. -33.98. In the year 2005, what is the difference between the Claims(annual growth as % of broad money) in Kazakhstan and Claims(annual growth as % of broad money) in Sao Tome and Principe?
Make the answer very short. 21.22. In the year 2006, what is the difference between the Claims(annual growth as % of broad money) in Cabo Verde and Claims(annual growth as % of broad money) in Croatia?
Provide a short and direct response. -6.79. In the year 2006, what is the difference between the Claims(annual growth as % of broad money) in Cabo Verde and Claims(annual growth as % of broad money) in Kazakhstan?
Your response must be concise. -91.36. In the year 2006, what is the difference between the Claims(annual growth as % of broad money) in Cabo Verde and Claims(annual growth as % of broad money) in Sao Tome and Principe?
Your answer should be compact. -19.43. In the year 2006, what is the difference between the Claims(annual growth as % of broad money) of Croatia and Claims(annual growth as % of broad money) of Kazakhstan?
Your answer should be compact. -84.57. In the year 2006, what is the difference between the Claims(annual growth as % of broad money) in Croatia and Claims(annual growth as % of broad money) in Sao Tome and Principe?
Make the answer very short. -12.64. In the year 2006, what is the difference between the Claims(annual growth as % of broad money) of Kazakhstan and Claims(annual growth as % of broad money) of Sao Tome and Principe?
Offer a terse response. 71.94. In the year 2007, what is the difference between the Claims(annual growth as % of broad money) in Cabo Verde and Claims(annual growth as % of broad money) in Croatia?
Your answer should be compact. -0.24. In the year 2007, what is the difference between the Claims(annual growth as % of broad money) of Cabo Verde and Claims(annual growth as % of broad money) of Kazakhstan?
Offer a very short reply. -59.34. In the year 2007, what is the difference between the Claims(annual growth as % of broad money) of Cabo Verde and Claims(annual growth as % of broad money) of Sao Tome and Principe?
Give a very brief answer. -13.73. In the year 2007, what is the difference between the Claims(annual growth as % of broad money) of Croatia and Claims(annual growth as % of broad money) of Kazakhstan?
Your answer should be compact. -59.09. In the year 2007, what is the difference between the Claims(annual growth as % of broad money) of Croatia and Claims(annual growth as % of broad money) of Sao Tome and Principe?
Offer a terse response. -13.49. In the year 2007, what is the difference between the Claims(annual growth as % of broad money) of Kazakhstan and Claims(annual growth as % of broad money) of Sao Tome and Principe?
Provide a short and direct response. 45.61. In the year 2008, what is the difference between the Claims(annual growth as % of broad money) in Cabo Verde and Claims(annual growth as % of broad money) in Croatia?
Make the answer very short. 4.72. In the year 2008, what is the difference between the Claims(annual growth as % of broad money) of Cabo Verde and Claims(annual growth as % of broad money) of Kazakhstan?
Make the answer very short. 7.18. In the year 2008, what is the difference between the Claims(annual growth as % of broad money) in Cabo Verde and Claims(annual growth as % of broad money) in Sao Tome and Principe?
Offer a terse response. -2.77. In the year 2008, what is the difference between the Claims(annual growth as % of broad money) of Croatia and Claims(annual growth as % of broad money) of Kazakhstan?
Keep it short and to the point. 2.46. In the year 2008, what is the difference between the Claims(annual growth as % of broad money) in Croatia and Claims(annual growth as % of broad money) in Sao Tome and Principe?
Give a very brief answer. -7.5. In the year 2008, what is the difference between the Claims(annual growth as % of broad money) in Kazakhstan and Claims(annual growth as % of broad money) in Sao Tome and Principe?
Make the answer very short. -9.95. In the year 2009, what is the difference between the Claims(annual growth as % of broad money) in Cabo Verde and Claims(annual growth as % of broad money) in Kazakhstan?
Your response must be concise. -1.08. In the year 2009, what is the difference between the Claims(annual growth as % of broad money) in Cabo Verde and Claims(annual growth as % of broad money) in Sao Tome and Principe?
Offer a terse response. -20.49. In the year 2009, what is the difference between the Claims(annual growth as % of broad money) in Kazakhstan and Claims(annual growth as % of broad money) in Sao Tome and Principe?
Your answer should be compact. -19.41. What is the ratio of the Claims(annual growth as % of broad money) of Cabo Verde in 2003 to that in 2004?
Keep it short and to the point. 1.45. What is the ratio of the Claims(annual growth as % of broad money) in Croatia in 2003 to that in 2004?
Your answer should be very brief. 1. What is the ratio of the Claims(annual growth as % of broad money) in Kazakhstan in 2003 to that in 2004?
Keep it short and to the point. 0.69. What is the ratio of the Claims(annual growth as % of broad money) in Cabo Verde in 2003 to that in 2005?
Ensure brevity in your answer.  1.66. What is the ratio of the Claims(annual growth as % of broad money) in Croatia in 2003 to that in 2005?
Make the answer very short. 0.82. What is the ratio of the Claims(annual growth as % of broad money) in Kazakhstan in 2003 to that in 2005?
Make the answer very short. 0.56. What is the ratio of the Claims(annual growth as % of broad money) of Sao Tome and Principe in 2003 to that in 2005?
Offer a terse response. 0.56. What is the ratio of the Claims(annual growth as % of broad money) in Cabo Verde in 2003 to that in 2006?
Provide a succinct answer. 0.51. What is the ratio of the Claims(annual growth as % of broad money) of Croatia in 2003 to that in 2006?
Ensure brevity in your answer.  0.58. What is the ratio of the Claims(annual growth as % of broad money) of Kazakhstan in 2003 to that in 2006?
Offer a terse response. 0.37. What is the ratio of the Claims(annual growth as % of broad money) in Sao Tome and Principe in 2003 to that in 2006?
Offer a very short reply. 0.81. What is the ratio of the Claims(annual growth as % of broad money) of Cabo Verde in 2003 to that in 2007?
Ensure brevity in your answer.  0.5. What is the ratio of the Claims(annual growth as % of broad money) in Croatia in 2003 to that in 2007?
Give a very brief answer. 0.84. What is the ratio of the Claims(annual growth as % of broad money) in Kazakhstan in 2003 to that in 2007?
Provide a succinct answer. 0.53. What is the ratio of the Claims(annual growth as % of broad money) of Sao Tome and Principe in 2003 to that in 2007?
Your answer should be compact. 0.98. What is the ratio of the Claims(annual growth as % of broad money) of Cabo Verde in 2003 to that in 2008?
Your answer should be compact. 0.44. What is the ratio of the Claims(annual growth as % of broad money) of Croatia in 2003 to that in 2008?
Offer a very short reply. 1.08. What is the ratio of the Claims(annual growth as % of broad money) in Kazakhstan in 2003 to that in 2008?
Offer a very short reply. 4.54. What is the ratio of the Claims(annual growth as % of broad money) in Sao Tome and Principe in 2003 to that in 2008?
Provide a succinct answer. 1.46. What is the ratio of the Claims(annual growth as % of broad money) in Cabo Verde in 2003 to that in 2009?
Provide a short and direct response. 0.86. What is the ratio of the Claims(annual growth as % of broad money) of Kazakhstan in 2003 to that in 2009?
Your response must be concise. 4.19. What is the ratio of the Claims(annual growth as % of broad money) in Sao Tome and Principe in 2003 to that in 2009?
Provide a succinct answer. 0.94. What is the ratio of the Claims(annual growth as % of broad money) of Cabo Verde in 2004 to that in 2005?
Your answer should be very brief. 1.14. What is the ratio of the Claims(annual growth as % of broad money) of Croatia in 2004 to that in 2005?
Offer a terse response. 0.82. What is the ratio of the Claims(annual growth as % of broad money) in Kazakhstan in 2004 to that in 2005?
Offer a very short reply. 0.81. What is the ratio of the Claims(annual growth as % of broad money) of Sao Tome and Principe in 2004 to that in 2005?
Keep it short and to the point. 0.56. What is the ratio of the Claims(annual growth as % of broad money) of Cabo Verde in 2004 to that in 2006?
Keep it short and to the point. 0.35. What is the ratio of the Claims(annual growth as % of broad money) of Croatia in 2004 to that in 2006?
Your answer should be compact. 0.57. What is the ratio of the Claims(annual growth as % of broad money) in Kazakhstan in 2004 to that in 2006?
Keep it short and to the point. 0.54. What is the ratio of the Claims(annual growth as % of broad money) of Sao Tome and Principe in 2004 to that in 2006?
Offer a terse response. 0.82. What is the ratio of the Claims(annual growth as % of broad money) of Cabo Verde in 2004 to that in 2007?
Your answer should be very brief. 0.35. What is the ratio of the Claims(annual growth as % of broad money) in Croatia in 2004 to that in 2007?
Provide a short and direct response. 0.83. What is the ratio of the Claims(annual growth as % of broad money) of Kazakhstan in 2004 to that in 2007?
Make the answer very short. 0.77. What is the ratio of the Claims(annual growth as % of broad money) of Sao Tome and Principe in 2004 to that in 2007?
Your response must be concise. 0.98. What is the ratio of the Claims(annual growth as % of broad money) in Cabo Verde in 2004 to that in 2008?
Ensure brevity in your answer.  0.31. What is the ratio of the Claims(annual growth as % of broad money) of Croatia in 2004 to that in 2008?
Provide a short and direct response. 1.07. What is the ratio of the Claims(annual growth as % of broad money) of Kazakhstan in 2004 to that in 2008?
Give a very brief answer. 6.61. What is the ratio of the Claims(annual growth as % of broad money) of Sao Tome and Principe in 2004 to that in 2008?
Provide a succinct answer. 1.47. What is the ratio of the Claims(annual growth as % of broad money) in Cabo Verde in 2004 to that in 2009?
Offer a terse response. 0.59. What is the ratio of the Claims(annual growth as % of broad money) of Kazakhstan in 2004 to that in 2009?
Offer a terse response. 6.11. What is the ratio of the Claims(annual growth as % of broad money) in Sao Tome and Principe in 2004 to that in 2009?
Give a very brief answer. 0.95. What is the ratio of the Claims(annual growth as % of broad money) of Cabo Verde in 2005 to that in 2006?
Give a very brief answer. 0.31. What is the ratio of the Claims(annual growth as % of broad money) in Croatia in 2005 to that in 2006?
Give a very brief answer. 0.7. What is the ratio of the Claims(annual growth as % of broad money) of Kazakhstan in 2005 to that in 2006?
Make the answer very short. 0.66. What is the ratio of the Claims(annual growth as % of broad money) of Sao Tome and Principe in 2005 to that in 2006?
Give a very brief answer. 1.46. What is the ratio of the Claims(annual growth as % of broad money) in Cabo Verde in 2005 to that in 2007?
Your answer should be compact. 0.3. What is the ratio of the Claims(annual growth as % of broad money) in Croatia in 2005 to that in 2007?
Your answer should be compact. 1.01. What is the ratio of the Claims(annual growth as % of broad money) in Kazakhstan in 2005 to that in 2007?
Provide a short and direct response. 0.95. What is the ratio of the Claims(annual growth as % of broad money) in Sao Tome and Principe in 2005 to that in 2007?
Ensure brevity in your answer.  1.75. What is the ratio of the Claims(annual growth as % of broad money) in Cabo Verde in 2005 to that in 2008?
Offer a very short reply. 0.27. What is the ratio of the Claims(annual growth as % of broad money) in Croatia in 2005 to that in 2008?
Offer a very short reply. 1.3. What is the ratio of the Claims(annual growth as % of broad money) of Kazakhstan in 2005 to that in 2008?
Your answer should be very brief. 8.13. What is the ratio of the Claims(annual growth as % of broad money) in Sao Tome and Principe in 2005 to that in 2008?
Offer a terse response. 2.61. What is the ratio of the Claims(annual growth as % of broad money) of Cabo Verde in 2005 to that in 2009?
Make the answer very short. 0.52. What is the ratio of the Claims(annual growth as % of broad money) of Kazakhstan in 2005 to that in 2009?
Offer a terse response. 7.52. What is the ratio of the Claims(annual growth as % of broad money) in Sao Tome and Principe in 2005 to that in 2009?
Provide a succinct answer. 1.69. What is the ratio of the Claims(annual growth as % of broad money) in Cabo Verde in 2006 to that in 2007?
Your response must be concise. 0.99. What is the ratio of the Claims(annual growth as % of broad money) in Croatia in 2006 to that in 2007?
Make the answer very short. 1.46. What is the ratio of the Claims(annual growth as % of broad money) of Kazakhstan in 2006 to that in 2007?
Provide a succinct answer. 1.44. What is the ratio of the Claims(annual growth as % of broad money) in Sao Tome and Principe in 2006 to that in 2007?
Provide a short and direct response. 1.2. What is the ratio of the Claims(annual growth as % of broad money) in Cabo Verde in 2006 to that in 2008?
Your response must be concise. 0.88. What is the ratio of the Claims(annual growth as % of broad money) of Croatia in 2006 to that in 2008?
Give a very brief answer. 1.87. What is the ratio of the Claims(annual growth as % of broad money) of Kazakhstan in 2006 to that in 2008?
Provide a short and direct response. 12.29. What is the ratio of the Claims(annual growth as % of broad money) in Sao Tome and Principe in 2006 to that in 2008?
Keep it short and to the point. 1.79. What is the ratio of the Claims(annual growth as % of broad money) of Cabo Verde in 2006 to that in 2009?
Make the answer very short. 1.69. What is the ratio of the Claims(annual growth as % of broad money) of Kazakhstan in 2006 to that in 2009?
Keep it short and to the point. 11.36. What is the ratio of the Claims(annual growth as % of broad money) of Sao Tome and Principe in 2006 to that in 2009?
Give a very brief answer. 1.16. What is the ratio of the Claims(annual growth as % of broad money) of Cabo Verde in 2007 to that in 2008?
Your answer should be very brief. 0.88. What is the ratio of the Claims(annual growth as % of broad money) of Croatia in 2007 to that in 2008?
Offer a very short reply. 1.28. What is the ratio of the Claims(annual growth as % of broad money) of Kazakhstan in 2007 to that in 2008?
Give a very brief answer. 8.56. What is the ratio of the Claims(annual growth as % of broad money) in Sao Tome and Principe in 2007 to that in 2008?
Your answer should be compact. 1.49. What is the ratio of the Claims(annual growth as % of broad money) of Cabo Verde in 2007 to that in 2009?
Offer a terse response. 1.7. What is the ratio of the Claims(annual growth as % of broad money) of Kazakhstan in 2007 to that in 2009?
Provide a short and direct response. 7.92. What is the ratio of the Claims(annual growth as % of broad money) of Sao Tome and Principe in 2007 to that in 2009?
Provide a succinct answer. 0.96. What is the ratio of the Claims(annual growth as % of broad money) in Cabo Verde in 2008 to that in 2009?
Give a very brief answer. 1.92. What is the ratio of the Claims(annual growth as % of broad money) of Kazakhstan in 2008 to that in 2009?
Ensure brevity in your answer.  0.92. What is the ratio of the Claims(annual growth as % of broad money) in Sao Tome and Principe in 2008 to that in 2009?
Ensure brevity in your answer.  0.65. What is the difference between the highest and the second highest Claims(annual growth as % of broad money) in Cabo Verde?
Keep it short and to the point. 1.83. What is the difference between the highest and the second highest Claims(annual growth as % of broad money) of Croatia?
Provide a succinct answer. 6.23. What is the difference between the highest and the second highest Claims(annual growth as % of broad money) of Kazakhstan?
Your answer should be compact. 31.92. What is the difference between the highest and the second highest Claims(annual growth as % of broad money) in Sao Tome and Principe?
Ensure brevity in your answer.  15.12. What is the difference between the highest and the lowest Claims(annual growth as % of broad money) of Cabo Verde?
Give a very brief answer. 11.51. What is the difference between the highest and the lowest Claims(annual growth as % of broad money) in Croatia?
Offer a terse response. 20.58. What is the difference between the highest and the lowest Claims(annual growth as % of broad money) of Kazakhstan?
Keep it short and to the point. 96.6. What is the difference between the highest and the lowest Claims(annual growth as % of broad money) of Sao Tome and Principe?
Provide a short and direct response. 29.83. 